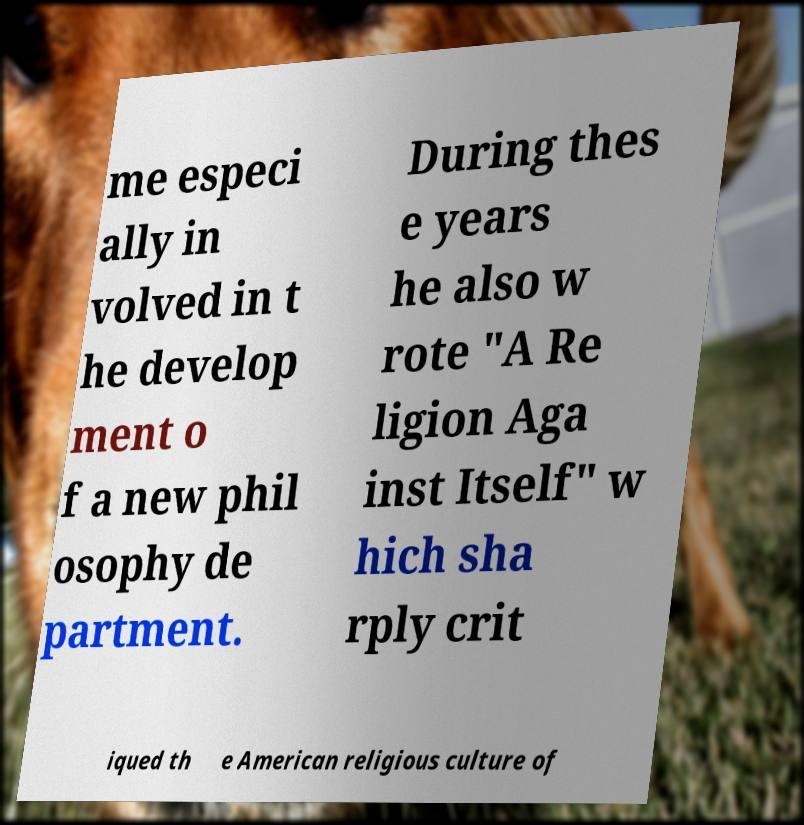I need the written content from this picture converted into text. Can you do that? me especi ally in volved in t he develop ment o f a new phil osophy de partment. During thes e years he also w rote "A Re ligion Aga inst Itself" w hich sha rply crit iqued th e American religious culture of 